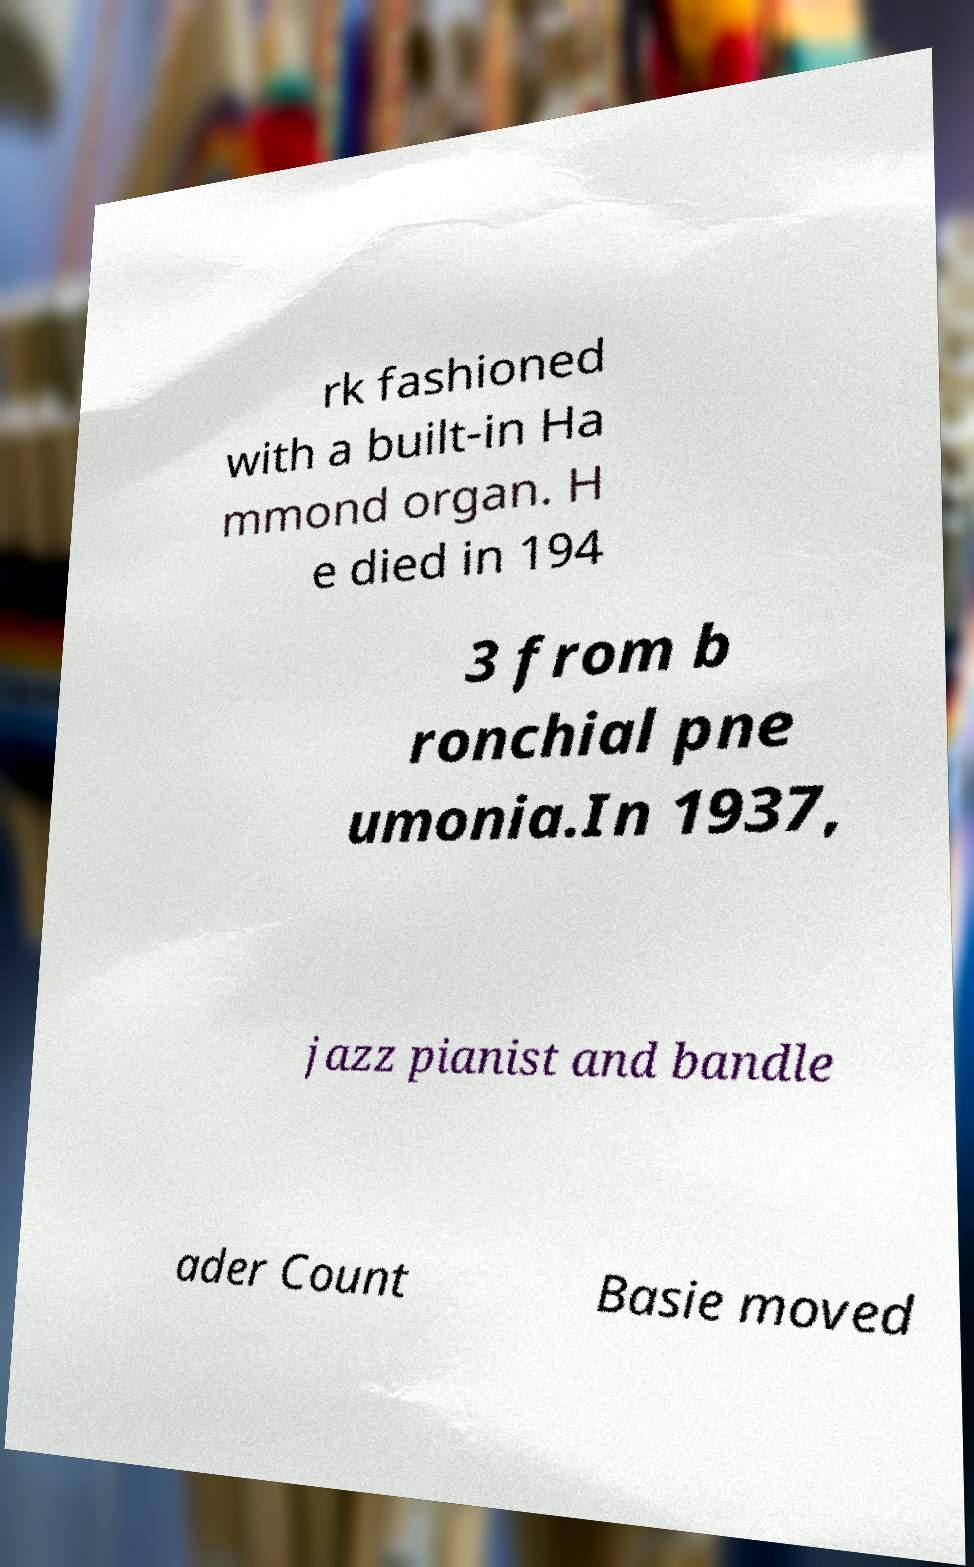Could you assist in decoding the text presented in this image and type it out clearly? rk fashioned with a built-in Ha mmond organ. H e died in 194 3 from b ronchial pne umonia.In 1937, jazz pianist and bandle ader Count Basie moved 